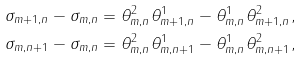Convert formula to latex. <formula><loc_0><loc_0><loc_500><loc_500>\sigma _ { m + 1 , n } - \sigma _ { m , n } & = \theta ^ { 2 } _ { m , n } \theta ^ { 1 } _ { m + 1 , n } - \theta ^ { 1 } _ { m , n } \theta ^ { 2 } _ { m + 1 , n } , \\ \sigma _ { m , n + 1 } - \sigma _ { m , n } & = \theta ^ { 2 } _ { m , n } \theta ^ { 1 } _ { m , n + 1 } - \theta ^ { 1 } _ { m , n } \theta ^ { 2 } _ { m , n + 1 } ,</formula> 